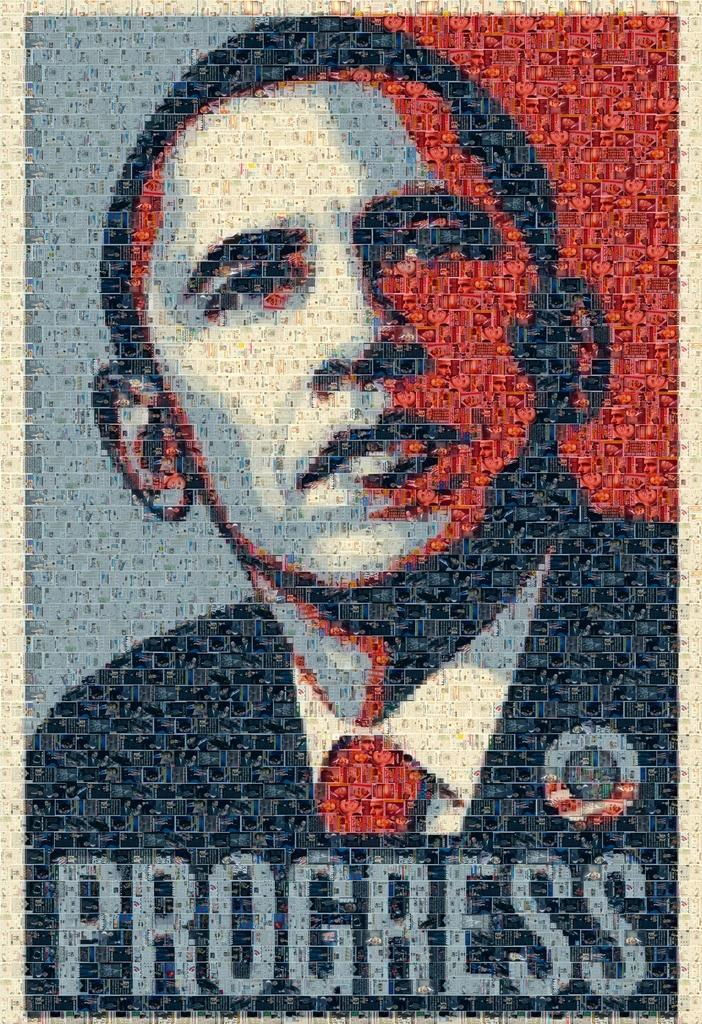What is the main subject of the poster in the image? The main subject of the poster in the image is a man. What colors are used to depict the man on the poster? The man is depicted in blue and red colors on the poster. What additional element can be seen below the man on the poster? There is a progress bar or similar element below the man on the poster. Can you see any boots on the man's feet in the image? There is no information about the man's feet or any boots in the image. Is there any fog visible in the image? There is no mention of fog in the provided facts, and it does not appear to be relevant to the image. 